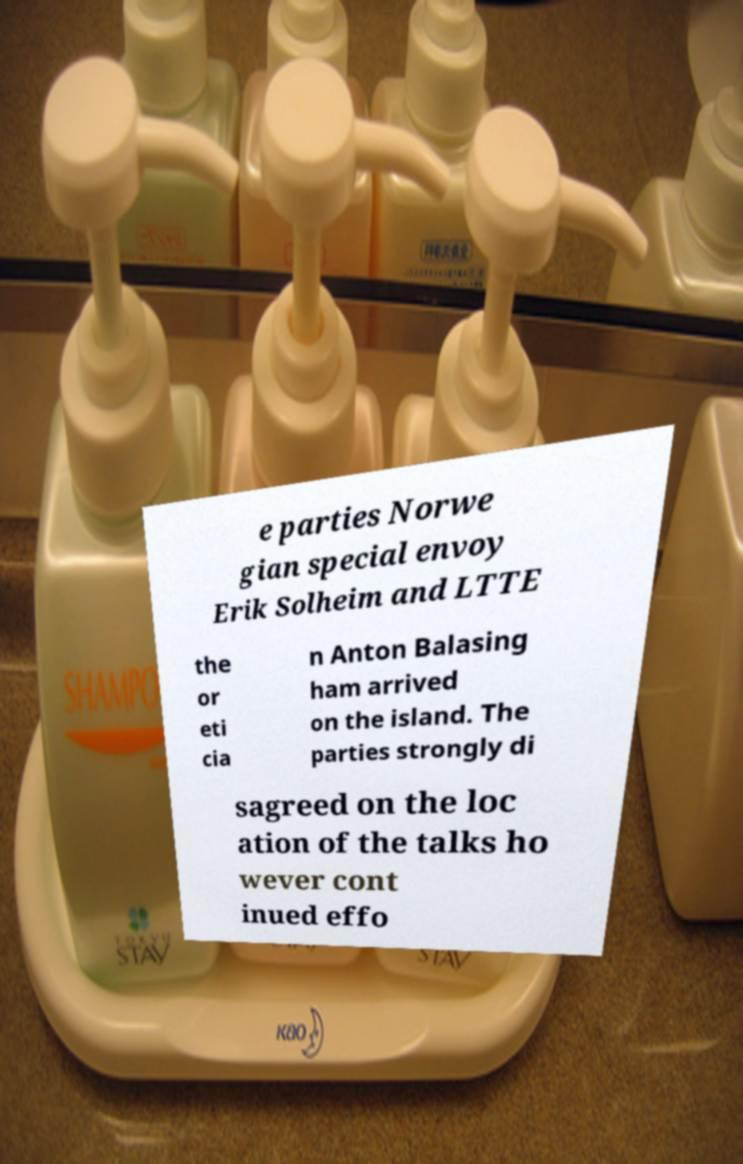Could you extract and type out the text from this image? e parties Norwe gian special envoy Erik Solheim and LTTE the or eti cia n Anton Balasing ham arrived on the island. The parties strongly di sagreed on the loc ation of the talks ho wever cont inued effo 